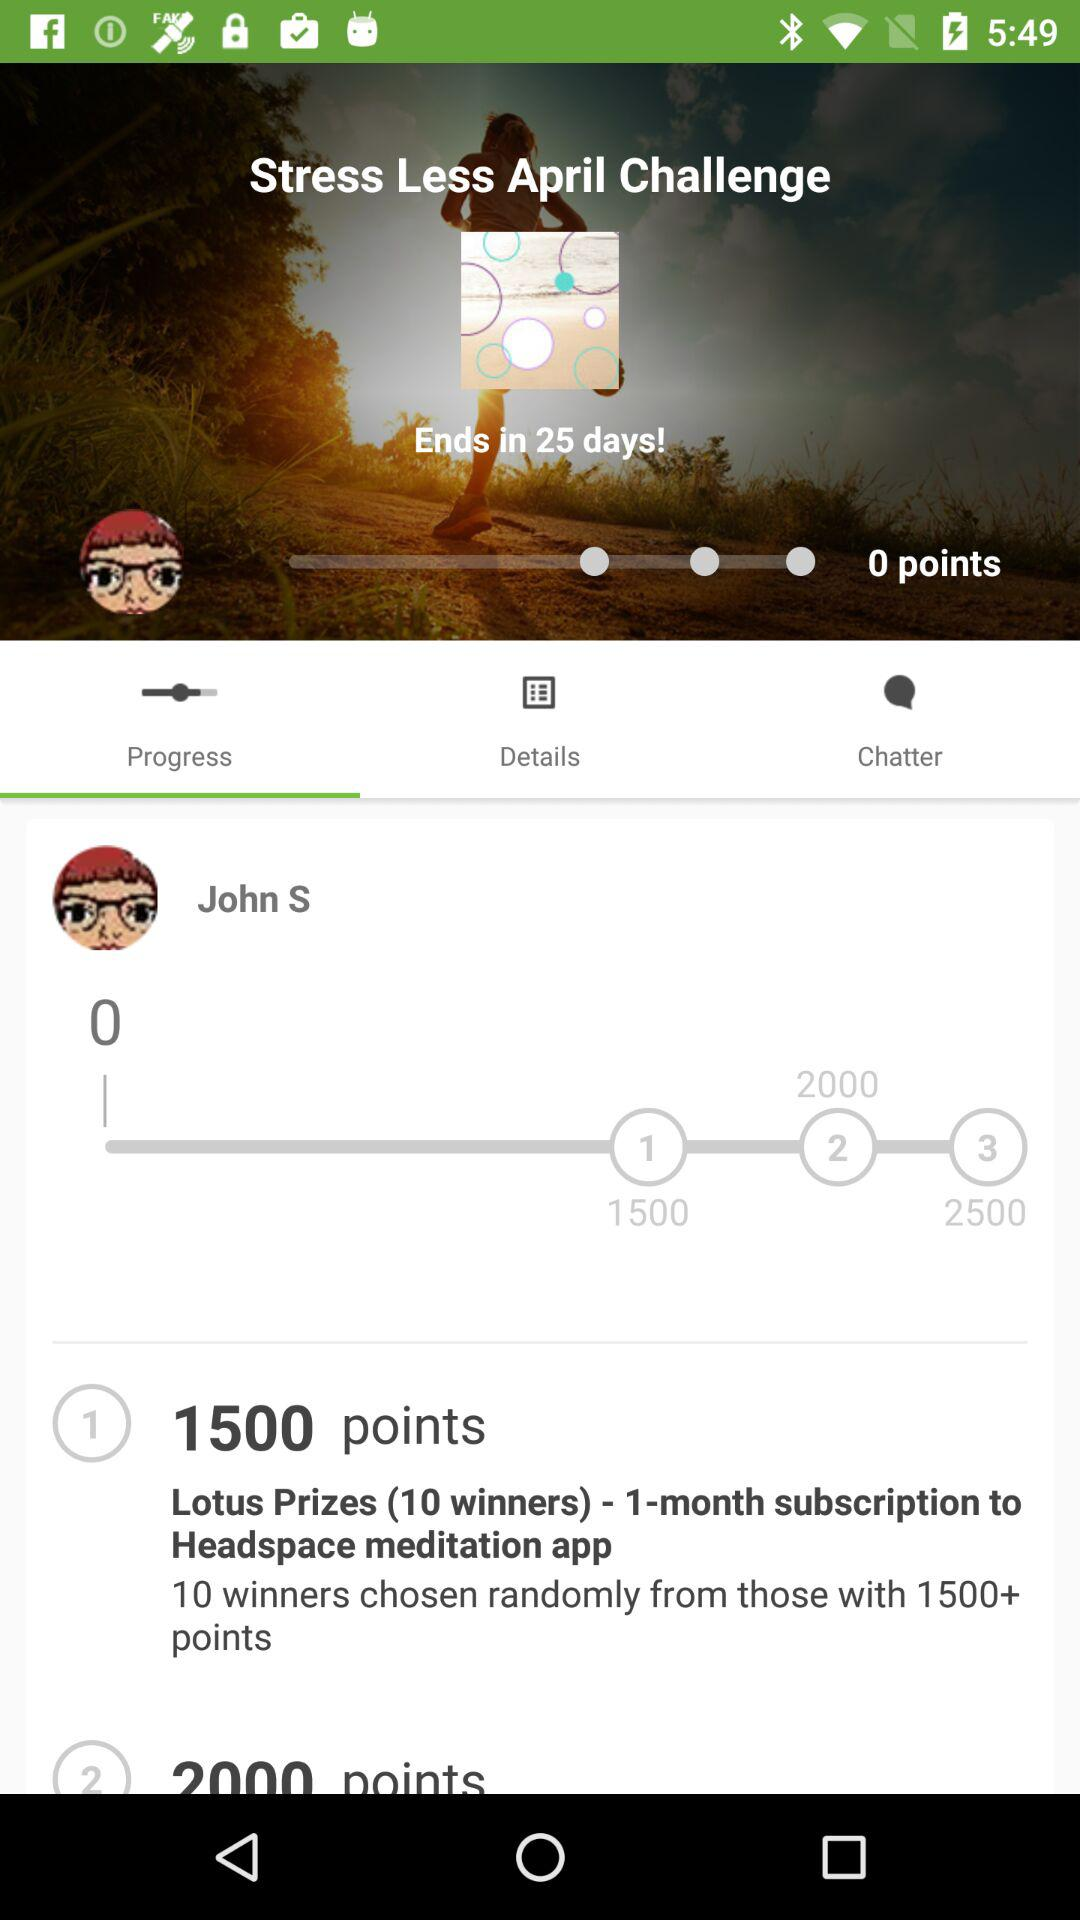How many points does the user have?
Answer the question using a single word or phrase. 0 